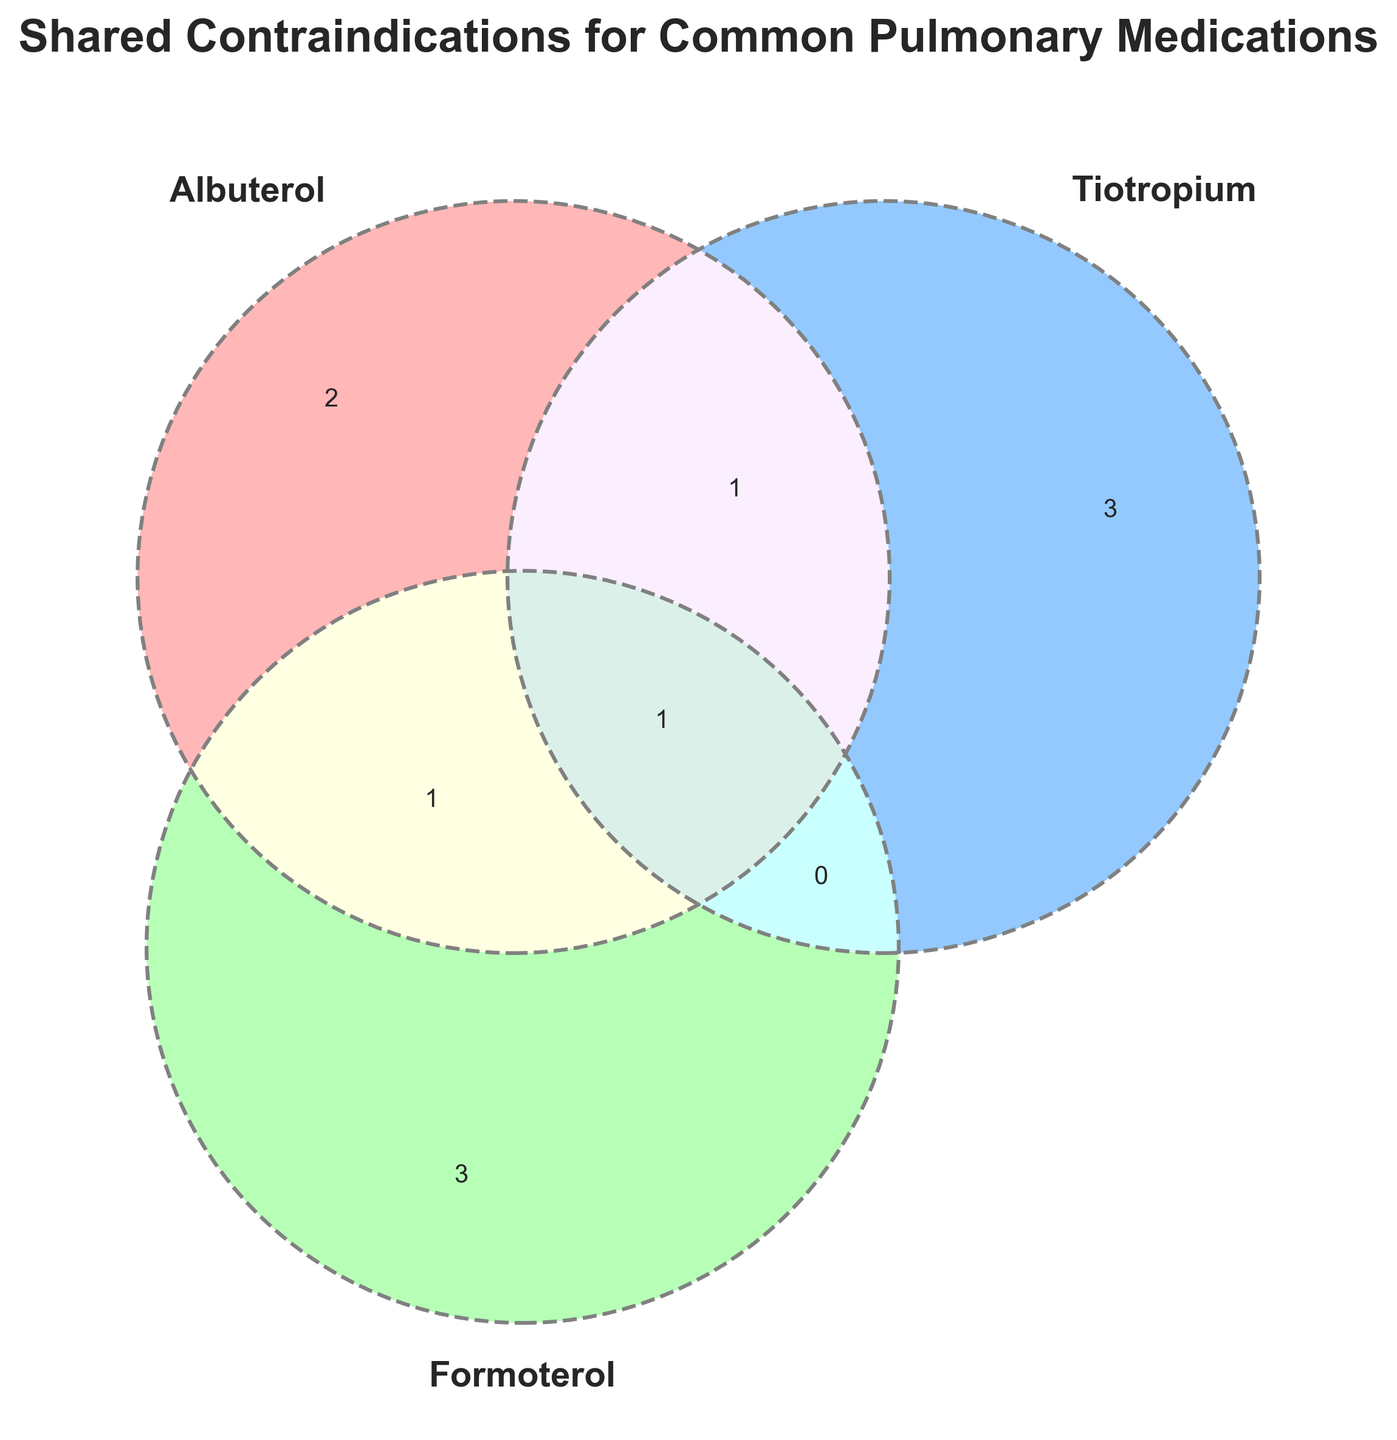What is the title of the figure? The title of the figure is usually found at the top of the plot. In this case, it indicates what the Venn diagram is showing.
Answer: Shared Contraindications for Common Pulmonary Medications How many sets are visualized in the Venn diagram? A Venn diagram can visualize multiple sets, usually represented by circles that overlap. In this instance, count the number of overlapping circles.
Answer: 3 Which three medications are included in the Venn diagram? The medications included in the Venn diagram are labeled typically above or beside the corresponding circles. Look for the names around the diagram.
Answer: Albuterol, Tiotropium, Formoterol What contraindications are shared by all three medications? The shared contraindications for all three medications are found in the overlapping region of all three circles. Identify what is written there.
Answer: Known hypersensitivity What contraindications are shared between Albuterol and Tiotropium but not Formoterol? Look for the region where the circles for Albuterol and Tiotropium overlap, excluding the section that also overlaps with Formoterol. The text within that region is the answer.
Answer: Hypersensitivity to anticholinergics Which medication has the contraindication of Tachycardia? Find the circle labeled "Albuterol" and look at the text inside it that is not overlapping with any other circles. Identify if Tachycardia is listed there.
Answer: Albuterol How many contraindications are unique to Formoterol? Identify the contraindications listed solely within the circle labeled "Formoterol" that do not overlap with any other circles. Count these items.
Answer: 2 Are there any contraindications shared by Formoterol and Tiotropium but not Albuterol? Search for the intersecting area between the circles labeled Formoterol and Tiotropium, excluding any intersection with Albuterol. Find if there are any contraindications listed in this specific intersection.
Answer: No What is the contraindication shared by Budesonide and Formoterol according to the information provided? Look for the section in the data where Budesonide and Formoterol intersect. The text listed in that intersection is what you need to identify.
Answer: Systemic corticosteroid use 